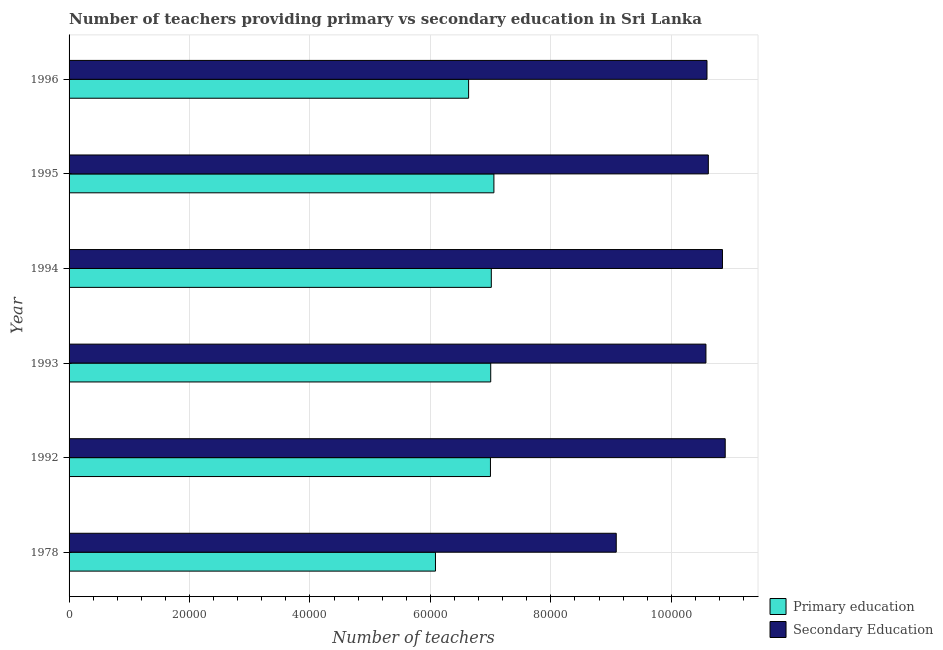How many different coloured bars are there?
Your answer should be very brief. 2. Are the number of bars on each tick of the Y-axis equal?
Your answer should be compact. Yes. How many bars are there on the 5th tick from the top?
Your answer should be very brief. 2. What is the number of secondary teachers in 1995?
Offer a very short reply. 1.06e+05. Across all years, what is the maximum number of secondary teachers?
Offer a terse response. 1.09e+05. Across all years, what is the minimum number of primary teachers?
Give a very brief answer. 6.08e+04. In which year was the number of primary teachers maximum?
Offer a terse response. 1995. In which year was the number of secondary teachers minimum?
Your response must be concise. 1978. What is the total number of primary teachers in the graph?
Your answer should be very brief. 4.08e+05. What is the difference between the number of secondary teachers in 1978 and that in 1995?
Your response must be concise. -1.53e+04. What is the difference between the number of primary teachers in 1992 and the number of secondary teachers in 1995?
Make the answer very short. -3.62e+04. What is the average number of primary teachers per year?
Your answer should be very brief. 6.80e+04. In the year 1995, what is the difference between the number of primary teachers and number of secondary teachers?
Make the answer very short. -3.56e+04. What is the difference between the highest and the second highest number of secondary teachers?
Provide a short and direct response. 455. What is the difference between the highest and the lowest number of secondary teachers?
Give a very brief answer. 1.81e+04. In how many years, is the number of secondary teachers greater than the average number of secondary teachers taken over all years?
Your response must be concise. 5. Is the sum of the number of secondary teachers in 1993 and 1994 greater than the maximum number of primary teachers across all years?
Make the answer very short. Yes. What does the 1st bar from the top in 1995 represents?
Your response must be concise. Secondary Education. What does the 2nd bar from the bottom in 1994 represents?
Your answer should be compact. Secondary Education. Are all the bars in the graph horizontal?
Your answer should be very brief. Yes. What is the difference between two consecutive major ticks on the X-axis?
Offer a very short reply. 2.00e+04. Are the values on the major ticks of X-axis written in scientific E-notation?
Give a very brief answer. No. Does the graph contain any zero values?
Keep it short and to the point. No. Where does the legend appear in the graph?
Ensure brevity in your answer.  Bottom right. What is the title of the graph?
Your answer should be very brief. Number of teachers providing primary vs secondary education in Sri Lanka. What is the label or title of the X-axis?
Make the answer very short. Number of teachers. What is the Number of teachers of Primary education in 1978?
Your response must be concise. 6.08e+04. What is the Number of teachers in Secondary Education in 1978?
Provide a succinct answer. 9.09e+04. What is the Number of teachers of Primary education in 1992?
Offer a terse response. 7.00e+04. What is the Number of teachers in Secondary Education in 1992?
Give a very brief answer. 1.09e+05. What is the Number of teachers in Primary education in 1993?
Make the answer very short. 7.00e+04. What is the Number of teachers of Secondary Education in 1993?
Offer a very short reply. 1.06e+05. What is the Number of teachers of Primary education in 1994?
Give a very brief answer. 7.01e+04. What is the Number of teachers of Secondary Education in 1994?
Ensure brevity in your answer.  1.08e+05. What is the Number of teachers in Primary education in 1995?
Offer a terse response. 7.05e+04. What is the Number of teachers in Secondary Education in 1995?
Offer a terse response. 1.06e+05. What is the Number of teachers in Primary education in 1996?
Offer a terse response. 6.63e+04. What is the Number of teachers of Secondary Education in 1996?
Ensure brevity in your answer.  1.06e+05. Across all years, what is the maximum Number of teachers of Primary education?
Make the answer very short. 7.05e+04. Across all years, what is the maximum Number of teachers of Secondary Education?
Keep it short and to the point. 1.09e+05. Across all years, what is the minimum Number of teachers in Primary education?
Give a very brief answer. 6.08e+04. Across all years, what is the minimum Number of teachers in Secondary Education?
Provide a short and direct response. 9.09e+04. What is the total Number of teachers of Primary education in the graph?
Make the answer very short. 4.08e+05. What is the total Number of teachers of Secondary Education in the graph?
Offer a terse response. 6.26e+05. What is the difference between the Number of teachers in Primary education in 1978 and that in 1992?
Your answer should be very brief. -9130. What is the difference between the Number of teachers of Secondary Education in 1978 and that in 1992?
Provide a succinct answer. -1.81e+04. What is the difference between the Number of teachers in Primary education in 1978 and that in 1993?
Ensure brevity in your answer.  -9173. What is the difference between the Number of teachers in Secondary Education in 1978 and that in 1993?
Give a very brief answer. -1.49e+04. What is the difference between the Number of teachers in Primary education in 1978 and that in 1994?
Provide a succinct answer. -9273. What is the difference between the Number of teachers in Secondary Education in 1978 and that in 1994?
Your answer should be very brief. -1.76e+04. What is the difference between the Number of teachers in Primary education in 1978 and that in 1995?
Offer a very short reply. -9702. What is the difference between the Number of teachers of Secondary Education in 1978 and that in 1995?
Your answer should be compact. -1.53e+04. What is the difference between the Number of teachers in Primary education in 1978 and that in 1996?
Your answer should be very brief. -5504. What is the difference between the Number of teachers of Secondary Education in 1978 and that in 1996?
Your answer should be compact. -1.51e+04. What is the difference between the Number of teachers in Primary education in 1992 and that in 1993?
Your answer should be compact. -43. What is the difference between the Number of teachers of Secondary Education in 1992 and that in 1993?
Offer a terse response. 3202. What is the difference between the Number of teachers in Primary education in 1992 and that in 1994?
Your answer should be compact. -143. What is the difference between the Number of teachers of Secondary Education in 1992 and that in 1994?
Ensure brevity in your answer.  455. What is the difference between the Number of teachers of Primary education in 1992 and that in 1995?
Offer a terse response. -572. What is the difference between the Number of teachers in Secondary Education in 1992 and that in 1995?
Ensure brevity in your answer.  2803. What is the difference between the Number of teachers of Primary education in 1992 and that in 1996?
Give a very brief answer. 3626. What is the difference between the Number of teachers of Secondary Education in 1992 and that in 1996?
Your answer should be very brief. 3028. What is the difference between the Number of teachers of Primary education in 1993 and that in 1994?
Provide a succinct answer. -100. What is the difference between the Number of teachers in Secondary Education in 1993 and that in 1994?
Provide a short and direct response. -2747. What is the difference between the Number of teachers of Primary education in 1993 and that in 1995?
Make the answer very short. -529. What is the difference between the Number of teachers of Secondary Education in 1993 and that in 1995?
Offer a very short reply. -399. What is the difference between the Number of teachers in Primary education in 1993 and that in 1996?
Provide a succinct answer. 3669. What is the difference between the Number of teachers in Secondary Education in 1993 and that in 1996?
Give a very brief answer. -174. What is the difference between the Number of teachers in Primary education in 1994 and that in 1995?
Your response must be concise. -429. What is the difference between the Number of teachers of Secondary Education in 1994 and that in 1995?
Ensure brevity in your answer.  2348. What is the difference between the Number of teachers of Primary education in 1994 and that in 1996?
Your answer should be very brief. 3769. What is the difference between the Number of teachers in Secondary Education in 1994 and that in 1996?
Your response must be concise. 2573. What is the difference between the Number of teachers in Primary education in 1995 and that in 1996?
Keep it short and to the point. 4198. What is the difference between the Number of teachers in Secondary Education in 1995 and that in 1996?
Keep it short and to the point. 225. What is the difference between the Number of teachers in Primary education in 1978 and the Number of teachers in Secondary Education in 1992?
Offer a very short reply. -4.81e+04. What is the difference between the Number of teachers in Primary education in 1978 and the Number of teachers in Secondary Education in 1993?
Make the answer very short. -4.49e+04. What is the difference between the Number of teachers of Primary education in 1978 and the Number of teachers of Secondary Education in 1994?
Keep it short and to the point. -4.77e+04. What is the difference between the Number of teachers in Primary education in 1978 and the Number of teachers in Secondary Education in 1995?
Your answer should be compact. -4.53e+04. What is the difference between the Number of teachers in Primary education in 1978 and the Number of teachers in Secondary Education in 1996?
Offer a terse response. -4.51e+04. What is the difference between the Number of teachers in Primary education in 1992 and the Number of teachers in Secondary Education in 1993?
Offer a terse response. -3.58e+04. What is the difference between the Number of teachers of Primary education in 1992 and the Number of teachers of Secondary Education in 1994?
Keep it short and to the point. -3.85e+04. What is the difference between the Number of teachers in Primary education in 1992 and the Number of teachers in Secondary Education in 1995?
Provide a short and direct response. -3.62e+04. What is the difference between the Number of teachers of Primary education in 1992 and the Number of teachers of Secondary Education in 1996?
Your response must be concise. -3.60e+04. What is the difference between the Number of teachers in Primary education in 1993 and the Number of teachers in Secondary Education in 1994?
Keep it short and to the point. -3.85e+04. What is the difference between the Number of teachers in Primary education in 1993 and the Number of teachers in Secondary Education in 1995?
Give a very brief answer. -3.61e+04. What is the difference between the Number of teachers in Primary education in 1993 and the Number of teachers in Secondary Education in 1996?
Provide a succinct answer. -3.59e+04. What is the difference between the Number of teachers in Primary education in 1994 and the Number of teachers in Secondary Education in 1995?
Ensure brevity in your answer.  -3.60e+04. What is the difference between the Number of teachers in Primary education in 1994 and the Number of teachers in Secondary Education in 1996?
Your answer should be compact. -3.58e+04. What is the difference between the Number of teachers of Primary education in 1995 and the Number of teachers of Secondary Education in 1996?
Provide a short and direct response. -3.54e+04. What is the average Number of teachers of Primary education per year?
Your response must be concise. 6.80e+04. What is the average Number of teachers in Secondary Education per year?
Offer a terse response. 1.04e+05. In the year 1978, what is the difference between the Number of teachers of Primary education and Number of teachers of Secondary Education?
Offer a terse response. -3.00e+04. In the year 1992, what is the difference between the Number of teachers in Primary education and Number of teachers in Secondary Education?
Ensure brevity in your answer.  -3.90e+04. In the year 1993, what is the difference between the Number of teachers in Primary education and Number of teachers in Secondary Education?
Your response must be concise. -3.57e+04. In the year 1994, what is the difference between the Number of teachers in Primary education and Number of teachers in Secondary Education?
Your response must be concise. -3.84e+04. In the year 1995, what is the difference between the Number of teachers in Primary education and Number of teachers in Secondary Education?
Your answer should be compact. -3.56e+04. In the year 1996, what is the difference between the Number of teachers of Primary education and Number of teachers of Secondary Education?
Your answer should be compact. -3.96e+04. What is the ratio of the Number of teachers in Primary education in 1978 to that in 1992?
Ensure brevity in your answer.  0.87. What is the ratio of the Number of teachers of Secondary Education in 1978 to that in 1992?
Offer a terse response. 0.83. What is the ratio of the Number of teachers of Primary education in 1978 to that in 1993?
Make the answer very short. 0.87. What is the ratio of the Number of teachers of Secondary Education in 1978 to that in 1993?
Provide a short and direct response. 0.86. What is the ratio of the Number of teachers in Primary education in 1978 to that in 1994?
Offer a very short reply. 0.87. What is the ratio of the Number of teachers of Secondary Education in 1978 to that in 1994?
Keep it short and to the point. 0.84. What is the ratio of the Number of teachers of Primary education in 1978 to that in 1995?
Your response must be concise. 0.86. What is the ratio of the Number of teachers in Secondary Education in 1978 to that in 1995?
Keep it short and to the point. 0.86. What is the ratio of the Number of teachers of Primary education in 1978 to that in 1996?
Give a very brief answer. 0.92. What is the ratio of the Number of teachers in Secondary Education in 1978 to that in 1996?
Keep it short and to the point. 0.86. What is the ratio of the Number of teachers in Primary education in 1992 to that in 1993?
Offer a terse response. 1. What is the ratio of the Number of teachers of Secondary Education in 1992 to that in 1993?
Give a very brief answer. 1.03. What is the ratio of the Number of teachers of Secondary Education in 1992 to that in 1994?
Make the answer very short. 1. What is the ratio of the Number of teachers in Secondary Education in 1992 to that in 1995?
Your response must be concise. 1.03. What is the ratio of the Number of teachers in Primary education in 1992 to that in 1996?
Your answer should be very brief. 1.05. What is the ratio of the Number of teachers of Secondary Education in 1992 to that in 1996?
Offer a very short reply. 1.03. What is the ratio of the Number of teachers in Secondary Education in 1993 to that in 1994?
Provide a succinct answer. 0.97. What is the ratio of the Number of teachers in Secondary Education in 1993 to that in 1995?
Your answer should be very brief. 1. What is the ratio of the Number of teachers of Primary education in 1993 to that in 1996?
Provide a short and direct response. 1.06. What is the ratio of the Number of teachers in Primary education in 1994 to that in 1995?
Give a very brief answer. 0.99. What is the ratio of the Number of teachers of Secondary Education in 1994 to that in 1995?
Offer a very short reply. 1.02. What is the ratio of the Number of teachers in Primary education in 1994 to that in 1996?
Your answer should be very brief. 1.06. What is the ratio of the Number of teachers of Secondary Education in 1994 to that in 1996?
Make the answer very short. 1.02. What is the ratio of the Number of teachers in Primary education in 1995 to that in 1996?
Offer a very short reply. 1.06. What is the difference between the highest and the second highest Number of teachers of Primary education?
Ensure brevity in your answer.  429. What is the difference between the highest and the second highest Number of teachers in Secondary Education?
Provide a short and direct response. 455. What is the difference between the highest and the lowest Number of teachers of Primary education?
Provide a succinct answer. 9702. What is the difference between the highest and the lowest Number of teachers of Secondary Education?
Ensure brevity in your answer.  1.81e+04. 